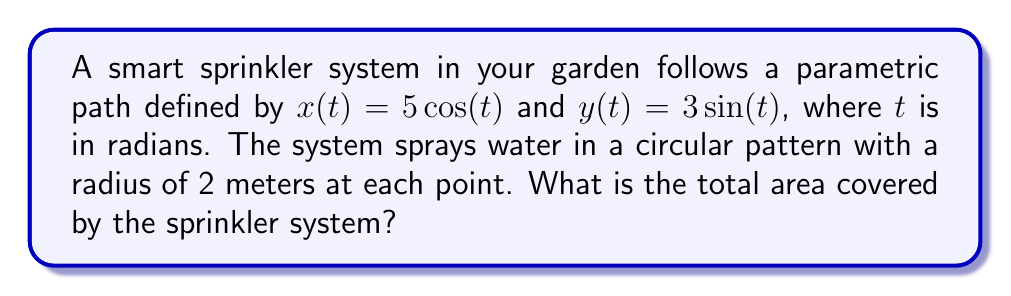Can you solve this math problem? Let's approach this step-by-step:

1) The parametric equations describe an ellipse. We can confirm this by squaring and adding the equations:

   $\frac{x^2}{25} + \frac{y^2}{9} = \cos^2(t) + \sin^2(t) = 1$

2) This is the standard form of an ellipse with semi-major axis $a = 5$ and semi-minor axis $b = 3$.

3) The area of an ellipse is given by the formula $A = \pi ab$. So the area of the elliptical path is:

   $A_{ellipse} = \pi(5)(3) = 15\pi$ square meters

4) Now, the sprinkler covers a circular area with radius 2m at each point. This effectively increases the semi-major and semi-minor axes by 2m each:

   $a_{covered} = 5 + 2 = 7$
   $b_{covered} = 3 + 2 = 5$

5) The total covered area is thus:

   $A_{covered} = \pi(7)(5) = 35\pi$ square meters

6) Therefore, the additional area covered beyond the elliptical path is:

   $A_{additional} = A_{covered} - A_{ellipse} = 35\pi - 15\pi = 20\pi$ square meters
Answer: $35\pi$ square meters 